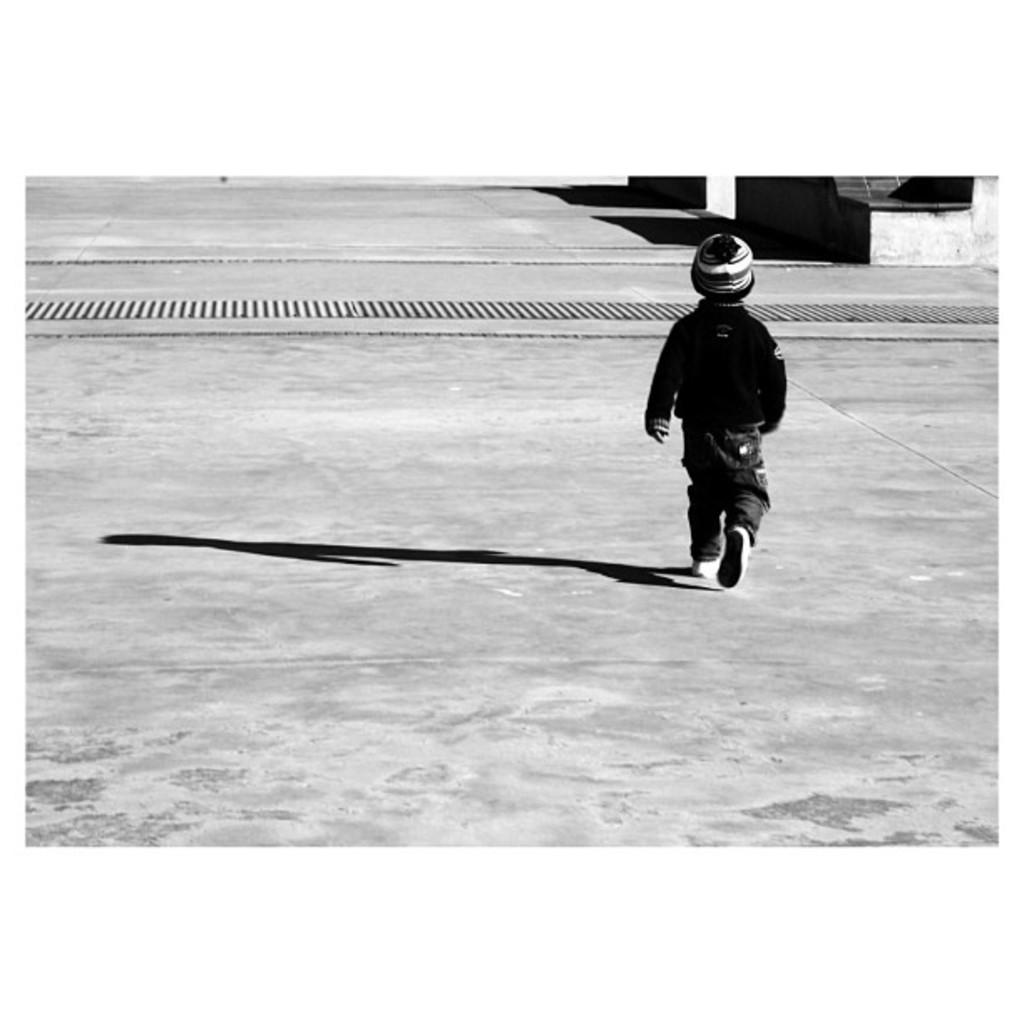What is the main subject of the image? There is a child in the image. What is the child wearing on their head? The child is wearing a cap. What is the child doing in the image? The child is walking. Can you describe the child's shadow in the image? There is a shadow of the child on the ground. What can be seen in the background of the image? There are objects visible in the background of the image. What type of flower is the child holding in the image? There is no flower present in the image; the child is wearing a cap and walking. 